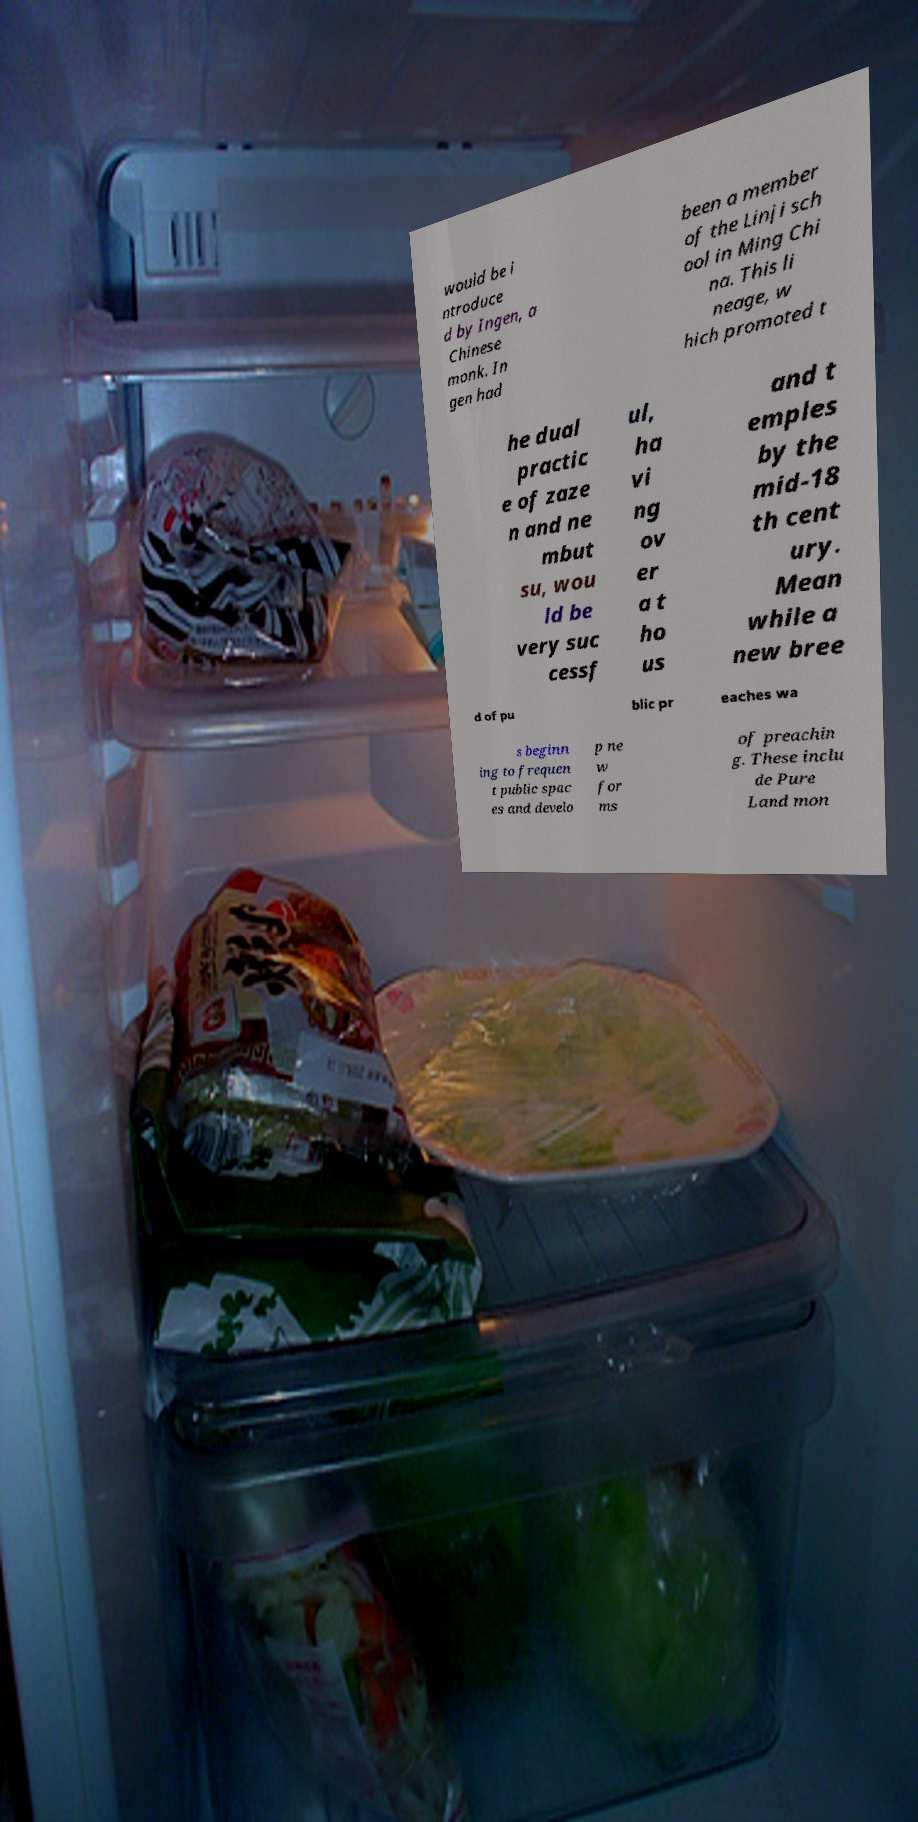Could you assist in decoding the text presented in this image and type it out clearly? would be i ntroduce d by Ingen, a Chinese monk. In gen had been a member of the Linji sch ool in Ming Chi na. This li neage, w hich promoted t he dual practic e of zaze n and ne mbut su, wou ld be very suc cessf ul, ha vi ng ov er a t ho us and t emples by the mid-18 th cent ury. Mean while a new bree d of pu blic pr eaches wa s beginn ing to frequen t public spac es and develo p ne w for ms of preachin g. These inclu de Pure Land mon 